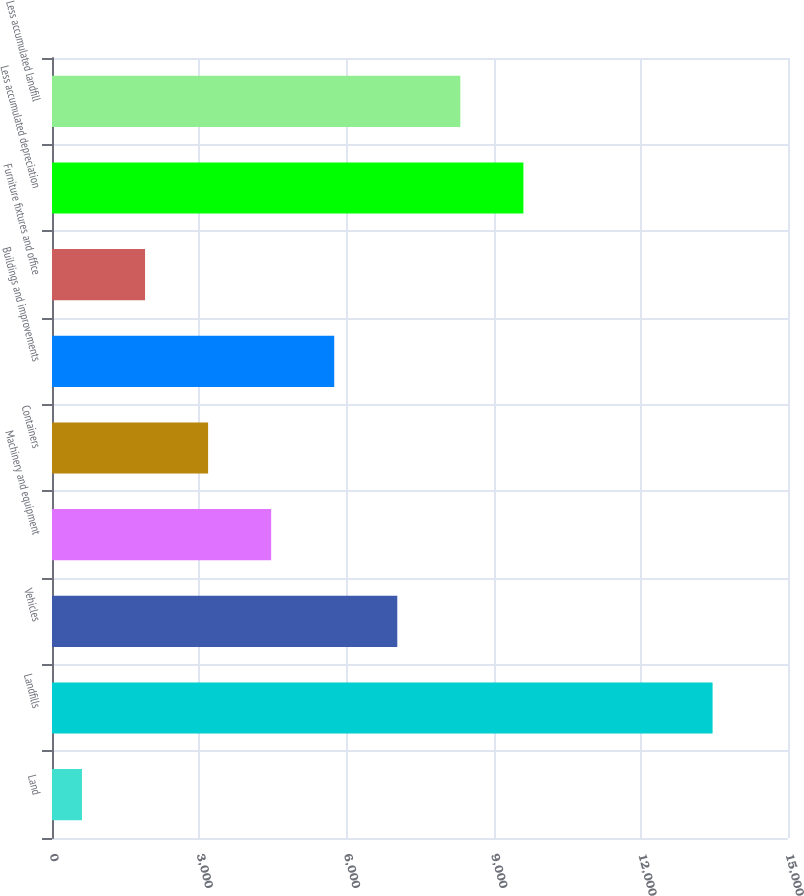Convert chart to OTSL. <chart><loc_0><loc_0><loc_500><loc_500><bar_chart><fcel>Land<fcel>Landfills<fcel>Vehicles<fcel>Machinery and equipment<fcel>Containers<fcel>Buildings and improvements<fcel>Furniture fixtures and office<fcel>Less accumulated depreciation<fcel>Less accumulated landfill<nl><fcel>611<fcel>13463<fcel>7037<fcel>4466.6<fcel>3181.4<fcel>5751.8<fcel>1896.2<fcel>9607.4<fcel>8322.2<nl></chart> 